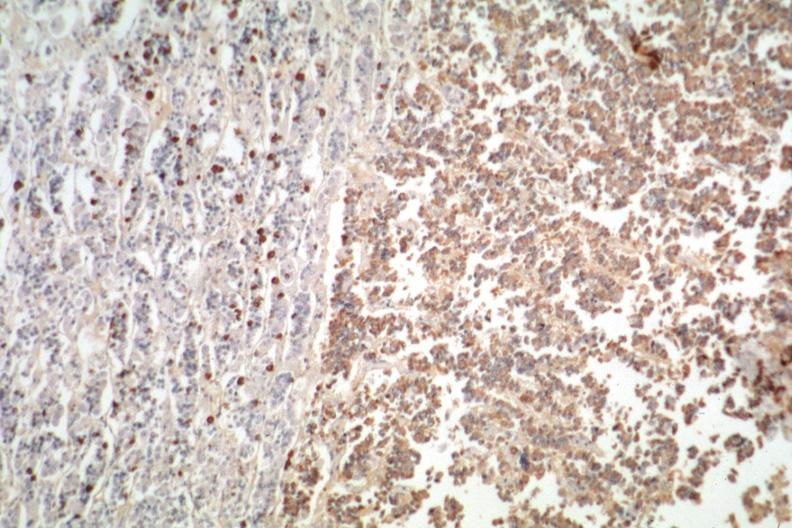how do immunostain for growth hormone stain is?
Answer the question using a single word or phrase. Positive 